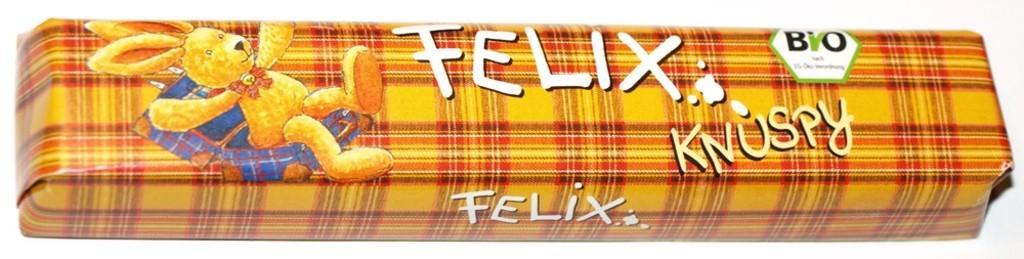Could you give a brief overview of what you see in this image? In this image we can see a object with some text and a cartoon on it. 